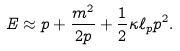Convert formula to latex. <formula><loc_0><loc_0><loc_500><loc_500>E \approx p + \frac { m ^ { 2 } } { 2 p } + \frac { 1 } { 2 } \kappa \ell _ { p } p ^ { 2 } .</formula> 